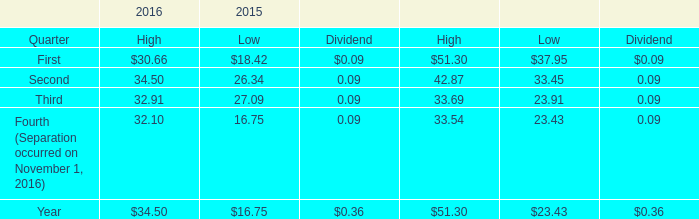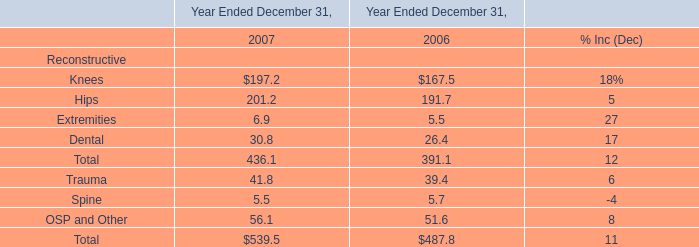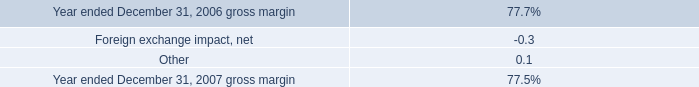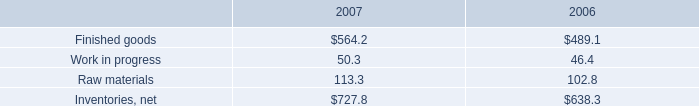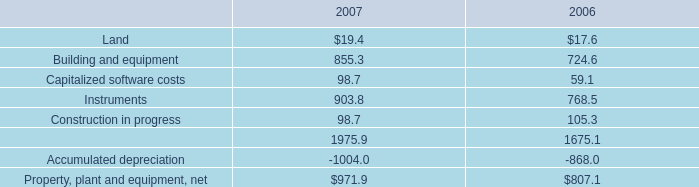As As the chart 3 shows, what's the increasing rate of the value of the Finished goods in the year where the value of the Raw materials is higher ? 
Computations: ((564.2 - 489.1) / 489.1)
Answer: 0.15355. 